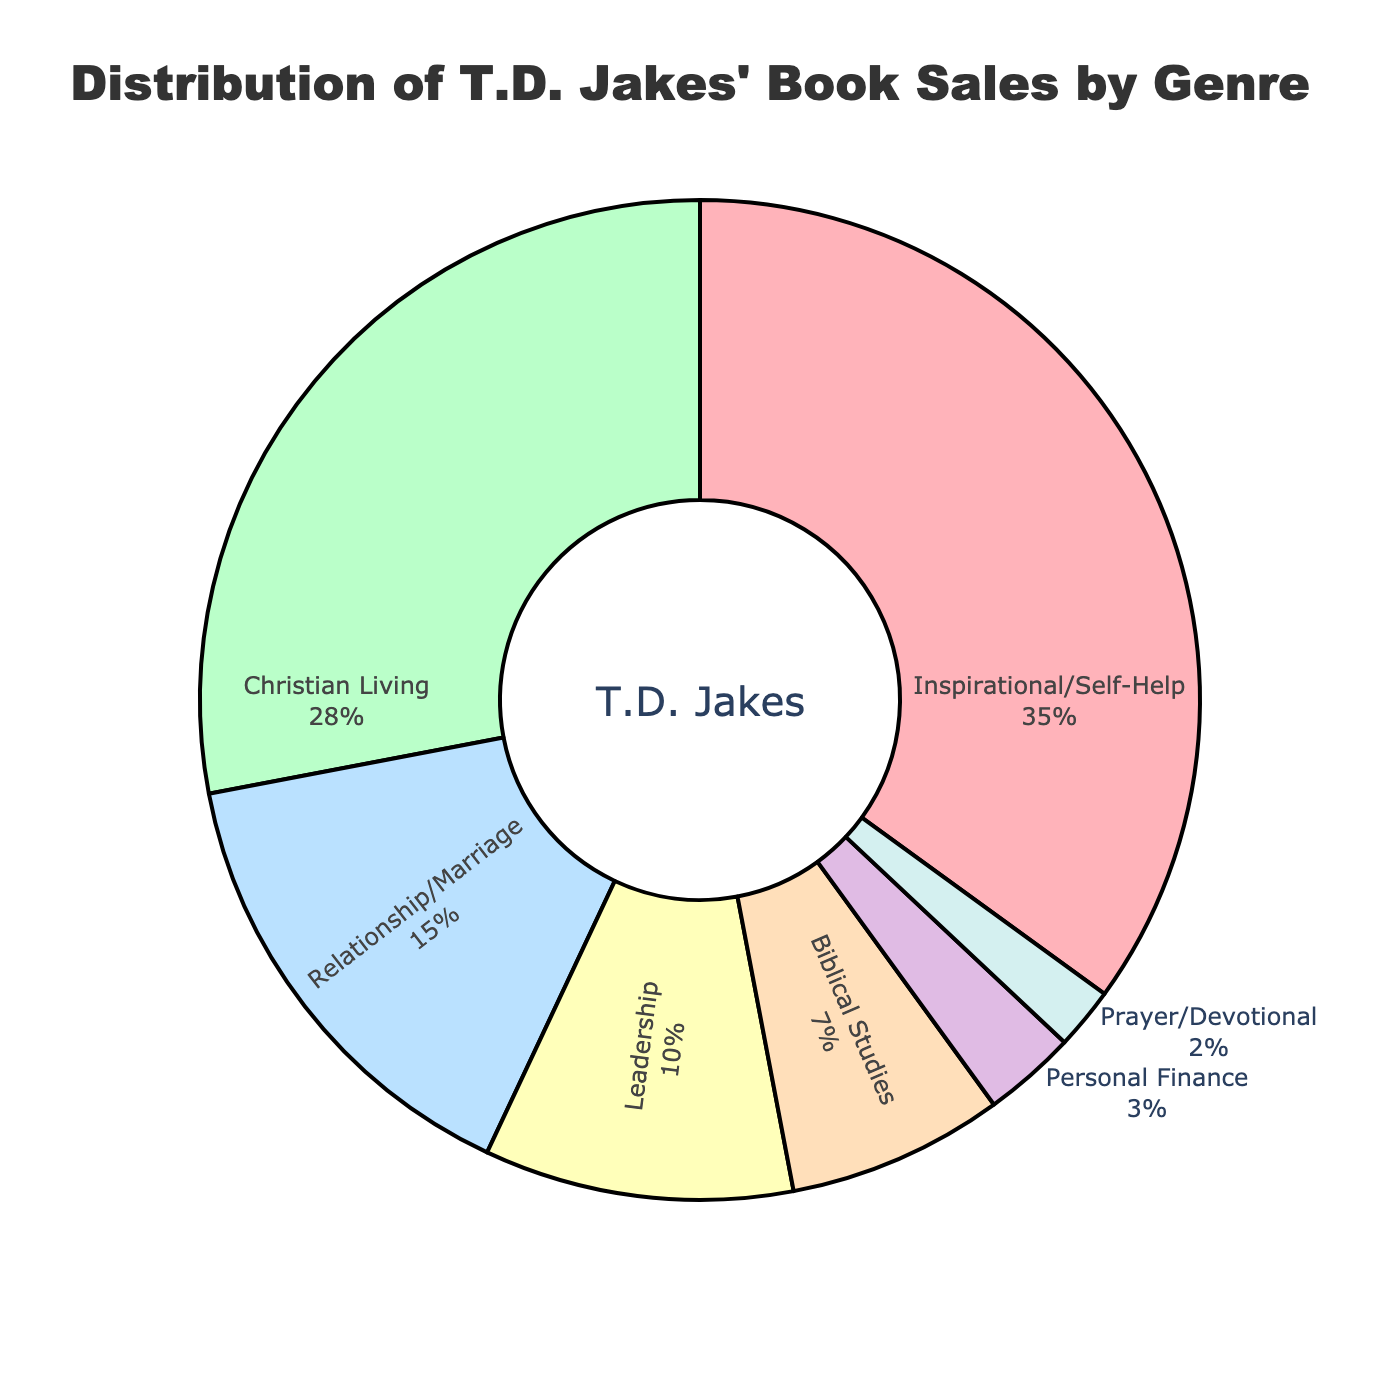What genre has the highest sales percentage? The genre with the highest percentage corresponds to the largest slice of the pie chart with the label. The largest slice is labeled "Inspirational/Self-Help" with 35%.
Answer: Inspirational/Self-Help What percentage of sales is from genres related to spirituality (Inspirational/Self-Help, Christian Living, Prayer/Devotional)? Add the percentages of Inspirational/Self-Help (35%), Christian Living (28%), and Prayer/Devotional (2%). The total is 35% + 28% + 2% = 65%.
Answer: 65% How do the sales percentages of Relationship/Marriage and Leadership compare? Compare the two slices of the pie chart labeled Relationship/Marriage (15%) and Leadership (10%). Relationship/Marriage has a larger percentage of sales than Leadership.
Answer: Relationship/Marriage has more Which genre has the smallest slice in the pie chart? The smallest slice of the pie chart is identified by the smallest percentage. The label for the smallest slice is "Prayer/Devotional" with 2%.
Answer: Prayer/Devotional What percentage of sales is from non-spiritual genres (Relationship/Marriage, Leadership, Personal Finance)? Add the percentages of Relationship/Marriage (15%), Leadership (10%), and Personal Finance (3%). The total is 15% + 10% + 3% = 28%.
Answer: 28% What is the difference in sales percentages between the top and bottom genres? Subtract the smallest percentage (Prayer/Devotional, 2%) from the largest percentage (Inspirational/Self-Help, 35%). The difference is 35% - 2% = 33%.
Answer: 33% What percentage of sales is from genres related to personal development (Inspirational/Self-Help, Leadership, Personal Finance)? Add the percentages of Inspirational/Self-Help (35%), Leadership (10%), and Personal Finance (3%). The total is 35% + 10% + 3% = 48%.
Answer: 48% Which genre has a sales percentage less than 10%? Identify slices of the pie chart with labels indicating less than 10%. The genres are Biblical Studies (7%), Personal Finance (3%), and Prayer/Devotional (2%).
Answer: Biblical Studies, Personal Finance, Prayer/Devotional 